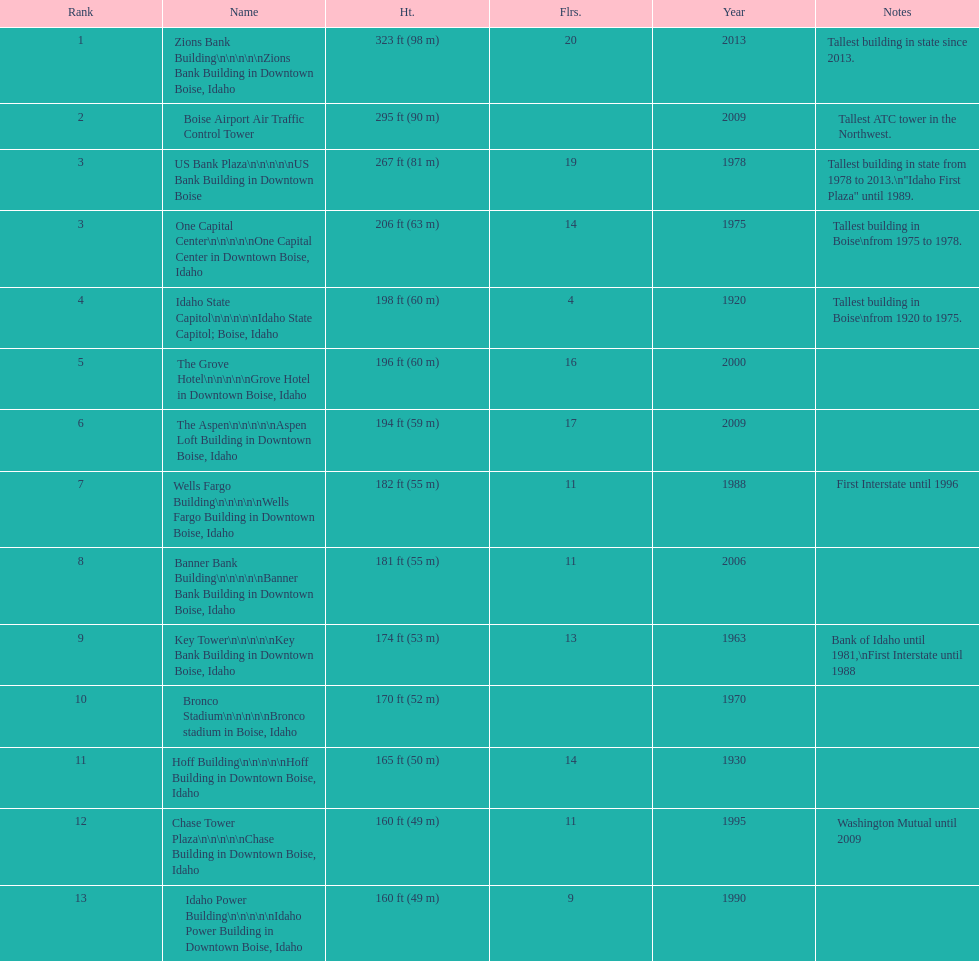What is the name of the building listed after idaho state capitol? The Grove Hotel. 